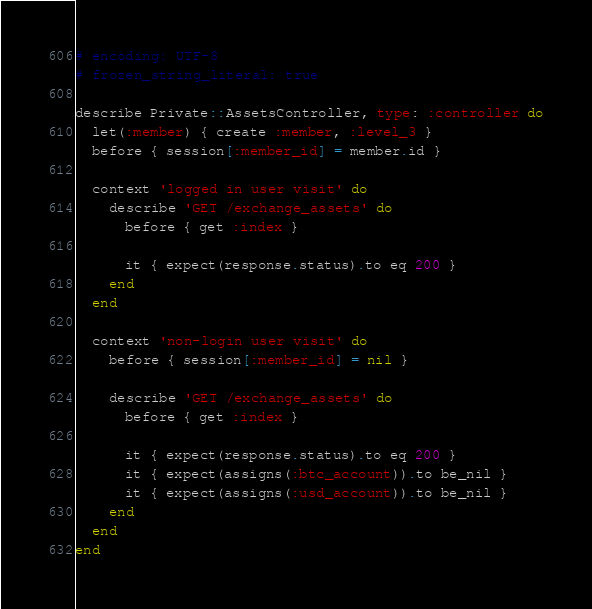<code> <loc_0><loc_0><loc_500><loc_500><_Ruby_># encoding: UTF-8
# frozen_string_literal: true

describe Private::AssetsController, type: :controller do
  let(:member) { create :member, :level_3 }
  before { session[:member_id] = member.id }

  context 'logged in user visit' do
    describe 'GET /exchange_assets' do
      before { get :index }

      it { expect(response.status).to eq 200 }
    end
  end

  context 'non-login user visit' do
    before { session[:member_id] = nil }

    describe 'GET /exchange_assets' do
      before { get :index }

      it { expect(response.status).to eq 200 }
      it { expect(assigns(:btc_account)).to be_nil }
      it { expect(assigns(:usd_account)).to be_nil }
    end
  end
end
</code> 